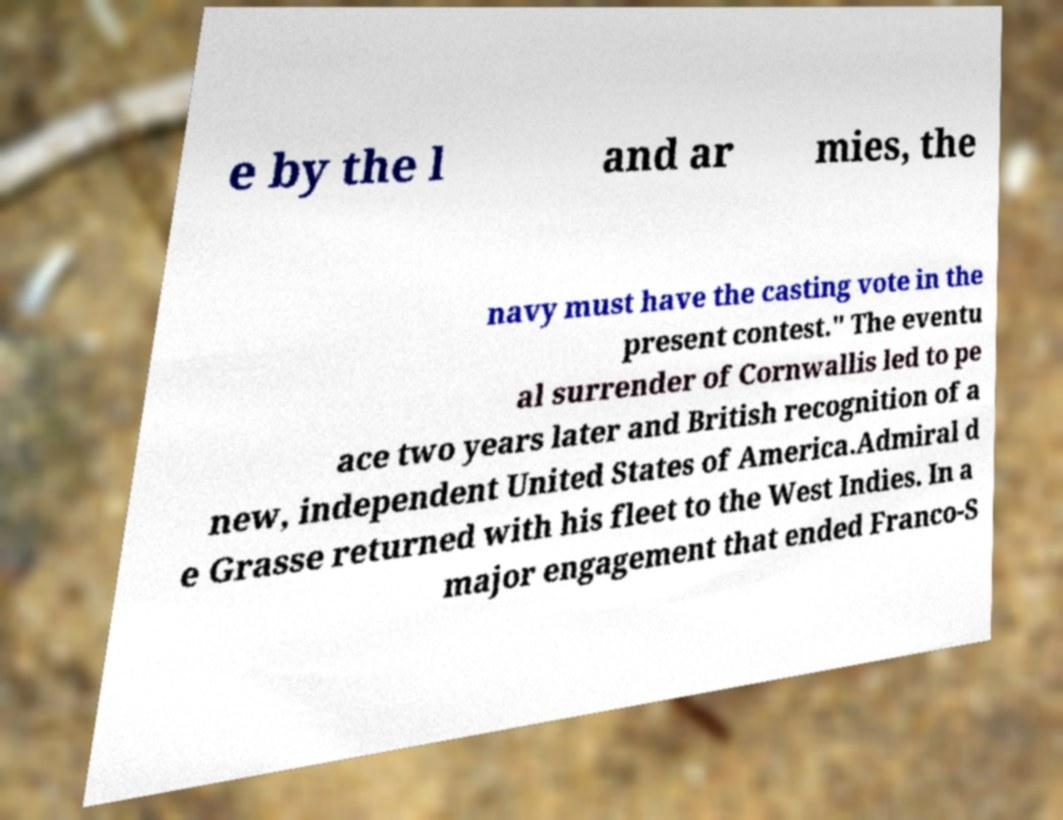Please identify and transcribe the text found in this image. e by the l and ar mies, the navy must have the casting vote in the present contest." The eventu al surrender of Cornwallis led to pe ace two years later and British recognition of a new, independent United States of America.Admiral d e Grasse returned with his fleet to the West Indies. In a major engagement that ended Franco-S 